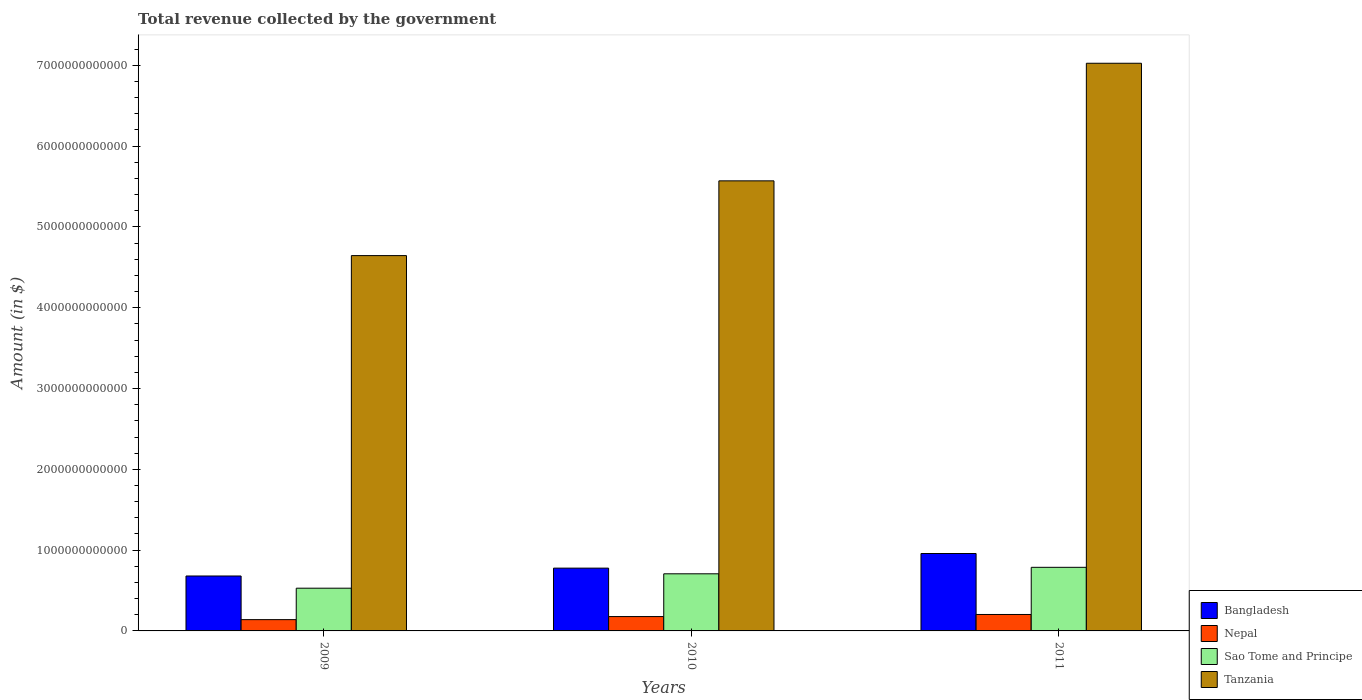How many groups of bars are there?
Your response must be concise. 3. How many bars are there on the 1st tick from the left?
Your answer should be compact. 4. How many bars are there on the 1st tick from the right?
Offer a terse response. 4. What is the total revenue collected by the government in Nepal in 2009?
Keep it short and to the point. 1.40e+11. Across all years, what is the maximum total revenue collected by the government in Bangladesh?
Give a very brief answer. 9.58e+11. Across all years, what is the minimum total revenue collected by the government in Bangladesh?
Provide a succinct answer. 6.80e+11. In which year was the total revenue collected by the government in Bangladesh maximum?
Provide a short and direct response. 2011. In which year was the total revenue collected by the government in Sao Tome and Principe minimum?
Make the answer very short. 2009. What is the total total revenue collected by the government in Tanzania in the graph?
Your response must be concise. 1.72e+13. What is the difference between the total revenue collected by the government in Tanzania in 2009 and that in 2011?
Offer a very short reply. -2.38e+12. What is the difference between the total revenue collected by the government in Sao Tome and Principe in 2011 and the total revenue collected by the government in Nepal in 2009?
Offer a very short reply. 6.48e+11. What is the average total revenue collected by the government in Sao Tome and Principe per year?
Provide a short and direct response. 6.74e+11. In the year 2011, what is the difference between the total revenue collected by the government in Sao Tome and Principe and total revenue collected by the government in Nepal?
Offer a very short reply. 5.84e+11. In how many years, is the total revenue collected by the government in Bangladesh greater than 4200000000000 $?
Make the answer very short. 0. What is the ratio of the total revenue collected by the government in Nepal in 2009 to that in 2011?
Your answer should be compact. 0.69. Is the difference between the total revenue collected by the government in Sao Tome and Principe in 2010 and 2011 greater than the difference between the total revenue collected by the government in Nepal in 2010 and 2011?
Keep it short and to the point. No. What is the difference between the highest and the second highest total revenue collected by the government in Tanzania?
Offer a terse response. 1.46e+12. What is the difference between the highest and the lowest total revenue collected by the government in Bangladesh?
Offer a very short reply. 2.78e+11. Is the sum of the total revenue collected by the government in Sao Tome and Principe in 2009 and 2010 greater than the maximum total revenue collected by the government in Bangladesh across all years?
Give a very brief answer. Yes. What does the 3rd bar from the left in 2011 represents?
Your response must be concise. Sao Tome and Principe. How many bars are there?
Provide a succinct answer. 12. Are all the bars in the graph horizontal?
Your answer should be compact. No. What is the difference between two consecutive major ticks on the Y-axis?
Offer a very short reply. 1.00e+12. Does the graph contain grids?
Provide a short and direct response. No. Where does the legend appear in the graph?
Make the answer very short. Bottom right. How many legend labels are there?
Keep it short and to the point. 4. What is the title of the graph?
Your response must be concise. Total revenue collected by the government. What is the label or title of the X-axis?
Provide a succinct answer. Years. What is the label or title of the Y-axis?
Keep it short and to the point. Amount (in $). What is the Amount (in $) of Bangladesh in 2009?
Keep it short and to the point. 6.80e+11. What is the Amount (in $) of Nepal in 2009?
Offer a very short reply. 1.40e+11. What is the Amount (in $) in Sao Tome and Principe in 2009?
Offer a terse response. 5.29e+11. What is the Amount (in $) of Tanzania in 2009?
Your answer should be very brief. 4.65e+12. What is the Amount (in $) of Bangladesh in 2010?
Offer a terse response. 7.77e+11. What is the Amount (in $) in Nepal in 2010?
Your answer should be very brief. 1.78e+11. What is the Amount (in $) in Sao Tome and Principe in 2010?
Give a very brief answer. 7.07e+11. What is the Amount (in $) in Tanzania in 2010?
Your answer should be compact. 5.57e+12. What is the Amount (in $) in Bangladesh in 2011?
Your response must be concise. 9.58e+11. What is the Amount (in $) in Nepal in 2011?
Make the answer very short. 2.04e+11. What is the Amount (in $) of Sao Tome and Principe in 2011?
Give a very brief answer. 7.87e+11. What is the Amount (in $) of Tanzania in 2011?
Ensure brevity in your answer.  7.03e+12. Across all years, what is the maximum Amount (in $) of Bangladesh?
Make the answer very short. 9.58e+11. Across all years, what is the maximum Amount (in $) in Nepal?
Provide a short and direct response. 2.04e+11. Across all years, what is the maximum Amount (in $) of Sao Tome and Principe?
Your response must be concise. 7.87e+11. Across all years, what is the maximum Amount (in $) of Tanzania?
Offer a terse response. 7.03e+12. Across all years, what is the minimum Amount (in $) in Bangladesh?
Offer a terse response. 6.80e+11. Across all years, what is the minimum Amount (in $) in Nepal?
Offer a terse response. 1.40e+11. Across all years, what is the minimum Amount (in $) of Sao Tome and Principe?
Give a very brief answer. 5.29e+11. Across all years, what is the minimum Amount (in $) of Tanzania?
Offer a very short reply. 4.65e+12. What is the total Amount (in $) of Bangladesh in the graph?
Ensure brevity in your answer.  2.42e+12. What is the total Amount (in $) of Nepal in the graph?
Make the answer very short. 5.21e+11. What is the total Amount (in $) in Sao Tome and Principe in the graph?
Provide a succinct answer. 2.02e+12. What is the total Amount (in $) of Tanzania in the graph?
Your answer should be very brief. 1.72e+13. What is the difference between the Amount (in $) in Bangladesh in 2009 and that in 2010?
Your answer should be very brief. -9.72e+1. What is the difference between the Amount (in $) in Nepal in 2009 and that in 2010?
Provide a short and direct response. -3.81e+1. What is the difference between the Amount (in $) of Sao Tome and Principe in 2009 and that in 2010?
Give a very brief answer. -1.78e+11. What is the difference between the Amount (in $) in Tanzania in 2009 and that in 2010?
Your answer should be compact. -9.25e+11. What is the difference between the Amount (in $) of Bangladesh in 2009 and that in 2011?
Make the answer very short. -2.78e+11. What is the difference between the Amount (in $) of Nepal in 2009 and that in 2011?
Make the answer very short. -6.39e+1. What is the difference between the Amount (in $) in Sao Tome and Principe in 2009 and that in 2011?
Your answer should be very brief. -2.58e+11. What is the difference between the Amount (in $) of Tanzania in 2009 and that in 2011?
Offer a very short reply. -2.38e+12. What is the difference between the Amount (in $) in Bangladesh in 2010 and that in 2011?
Keep it short and to the point. -1.81e+11. What is the difference between the Amount (in $) in Nepal in 2010 and that in 2011?
Provide a short and direct response. -2.59e+1. What is the difference between the Amount (in $) in Sao Tome and Principe in 2010 and that in 2011?
Offer a terse response. -8.03e+1. What is the difference between the Amount (in $) of Tanzania in 2010 and that in 2011?
Offer a terse response. -1.46e+12. What is the difference between the Amount (in $) in Bangladesh in 2009 and the Amount (in $) in Nepal in 2010?
Your answer should be compact. 5.02e+11. What is the difference between the Amount (in $) of Bangladesh in 2009 and the Amount (in $) of Sao Tome and Principe in 2010?
Provide a short and direct response. -2.70e+1. What is the difference between the Amount (in $) in Bangladesh in 2009 and the Amount (in $) in Tanzania in 2010?
Your answer should be very brief. -4.89e+12. What is the difference between the Amount (in $) of Nepal in 2009 and the Amount (in $) of Sao Tome and Principe in 2010?
Provide a succinct answer. -5.67e+11. What is the difference between the Amount (in $) of Nepal in 2009 and the Amount (in $) of Tanzania in 2010?
Keep it short and to the point. -5.43e+12. What is the difference between the Amount (in $) of Sao Tome and Principe in 2009 and the Amount (in $) of Tanzania in 2010?
Give a very brief answer. -5.04e+12. What is the difference between the Amount (in $) in Bangladesh in 2009 and the Amount (in $) in Nepal in 2011?
Make the answer very short. 4.76e+11. What is the difference between the Amount (in $) in Bangladesh in 2009 and the Amount (in $) in Sao Tome and Principe in 2011?
Your answer should be compact. -1.07e+11. What is the difference between the Amount (in $) of Bangladesh in 2009 and the Amount (in $) of Tanzania in 2011?
Offer a very short reply. -6.35e+12. What is the difference between the Amount (in $) in Nepal in 2009 and the Amount (in $) in Sao Tome and Principe in 2011?
Your answer should be compact. -6.48e+11. What is the difference between the Amount (in $) of Nepal in 2009 and the Amount (in $) of Tanzania in 2011?
Your answer should be compact. -6.89e+12. What is the difference between the Amount (in $) of Sao Tome and Principe in 2009 and the Amount (in $) of Tanzania in 2011?
Keep it short and to the point. -6.50e+12. What is the difference between the Amount (in $) in Bangladesh in 2010 and the Amount (in $) in Nepal in 2011?
Make the answer very short. 5.74e+11. What is the difference between the Amount (in $) of Bangladesh in 2010 and the Amount (in $) of Sao Tome and Principe in 2011?
Keep it short and to the point. -1.01e+1. What is the difference between the Amount (in $) in Bangladesh in 2010 and the Amount (in $) in Tanzania in 2011?
Offer a very short reply. -6.25e+12. What is the difference between the Amount (in $) of Nepal in 2010 and the Amount (in $) of Sao Tome and Principe in 2011?
Provide a short and direct response. -6.10e+11. What is the difference between the Amount (in $) of Nepal in 2010 and the Amount (in $) of Tanzania in 2011?
Make the answer very short. -6.85e+12. What is the difference between the Amount (in $) of Sao Tome and Principe in 2010 and the Amount (in $) of Tanzania in 2011?
Keep it short and to the point. -6.32e+12. What is the average Amount (in $) of Bangladesh per year?
Provide a short and direct response. 8.05e+11. What is the average Amount (in $) in Nepal per year?
Your response must be concise. 1.74e+11. What is the average Amount (in $) of Sao Tome and Principe per year?
Your answer should be very brief. 6.74e+11. What is the average Amount (in $) of Tanzania per year?
Give a very brief answer. 5.75e+12. In the year 2009, what is the difference between the Amount (in $) in Bangladesh and Amount (in $) in Nepal?
Make the answer very short. 5.40e+11. In the year 2009, what is the difference between the Amount (in $) in Bangladesh and Amount (in $) in Sao Tome and Principe?
Your answer should be compact. 1.51e+11. In the year 2009, what is the difference between the Amount (in $) in Bangladesh and Amount (in $) in Tanzania?
Your response must be concise. -3.97e+12. In the year 2009, what is the difference between the Amount (in $) of Nepal and Amount (in $) of Sao Tome and Principe?
Offer a terse response. -3.89e+11. In the year 2009, what is the difference between the Amount (in $) in Nepal and Amount (in $) in Tanzania?
Ensure brevity in your answer.  -4.51e+12. In the year 2009, what is the difference between the Amount (in $) of Sao Tome and Principe and Amount (in $) of Tanzania?
Your response must be concise. -4.12e+12. In the year 2010, what is the difference between the Amount (in $) of Bangladesh and Amount (in $) of Nepal?
Ensure brevity in your answer.  5.99e+11. In the year 2010, what is the difference between the Amount (in $) of Bangladesh and Amount (in $) of Sao Tome and Principe?
Ensure brevity in your answer.  7.02e+1. In the year 2010, what is the difference between the Amount (in $) of Bangladesh and Amount (in $) of Tanzania?
Make the answer very short. -4.79e+12. In the year 2010, what is the difference between the Amount (in $) in Nepal and Amount (in $) in Sao Tome and Principe?
Your response must be concise. -5.29e+11. In the year 2010, what is the difference between the Amount (in $) in Nepal and Amount (in $) in Tanzania?
Your answer should be very brief. -5.39e+12. In the year 2010, what is the difference between the Amount (in $) in Sao Tome and Principe and Amount (in $) in Tanzania?
Make the answer very short. -4.86e+12. In the year 2011, what is the difference between the Amount (in $) of Bangladesh and Amount (in $) of Nepal?
Your answer should be very brief. 7.55e+11. In the year 2011, what is the difference between the Amount (in $) of Bangladesh and Amount (in $) of Sao Tome and Principe?
Provide a succinct answer. 1.71e+11. In the year 2011, what is the difference between the Amount (in $) of Bangladesh and Amount (in $) of Tanzania?
Give a very brief answer. -6.07e+12. In the year 2011, what is the difference between the Amount (in $) in Nepal and Amount (in $) in Sao Tome and Principe?
Offer a very short reply. -5.84e+11. In the year 2011, what is the difference between the Amount (in $) in Nepal and Amount (in $) in Tanzania?
Your answer should be very brief. -6.82e+12. In the year 2011, what is the difference between the Amount (in $) in Sao Tome and Principe and Amount (in $) in Tanzania?
Provide a short and direct response. -6.24e+12. What is the ratio of the Amount (in $) in Bangladesh in 2009 to that in 2010?
Keep it short and to the point. 0.87. What is the ratio of the Amount (in $) of Nepal in 2009 to that in 2010?
Provide a succinct answer. 0.79. What is the ratio of the Amount (in $) of Sao Tome and Principe in 2009 to that in 2010?
Your answer should be very brief. 0.75. What is the ratio of the Amount (in $) of Tanzania in 2009 to that in 2010?
Make the answer very short. 0.83. What is the ratio of the Amount (in $) in Bangladesh in 2009 to that in 2011?
Provide a succinct answer. 0.71. What is the ratio of the Amount (in $) of Nepal in 2009 to that in 2011?
Give a very brief answer. 0.69. What is the ratio of the Amount (in $) of Sao Tome and Principe in 2009 to that in 2011?
Give a very brief answer. 0.67. What is the ratio of the Amount (in $) in Tanzania in 2009 to that in 2011?
Give a very brief answer. 0.66. What is the ratio of the Amount (in $) of Bangladesh in 2010 to that in 2011?
Ensure brevity in your answer.  0.81. What is the ratio of the Amount (in $) in Nepal in 2010 to that in 2011?
Your answer should be compact. 0.87. What is the ratio of the Amount (in $) of Sao Tome and Principe in 2010 to that in 2011?
Give a very brief answer. 0.9. What is the ratio of the Amount (in $) of Tanzania in 2010 to that in 2011?
Make the answer very short. 0.79. What is the difference between the highest and the second highest Amount (in $) of Bangladesh?
Keep it short and to the point. 1.81e+11. What is the difference between the highest and the second highest Amount (in $) in Nepal?
Provide a succinct answer. 2.59e+1. What is the difference between the highest and the second highest Amount (in $) in Sao Tome and Principe?
Offer a very short reply. 8.03e+1. What is the difference between the highest and the second highest Amount (in $) in Tanzania?
Offer a terse response. 1.46e+12. What is the difference between the highest and the lowest Amount (in $) of Bangladesh?
Your answer should be compact. 2.78e+11. What is the difference between the highest and the lowest Amount (in $) in Nepal?
Ensure brevity in your answer.  6.39e+1. What is the difference between the highest and the lowest Amount (in $) in Sao Tome and Principe?
Offer a very short reply. 2.58e+11. What is the difference between the highest and the lowest Amount (in $) in Tanzania?
Your answer should be very brief. 2.38e+12. 